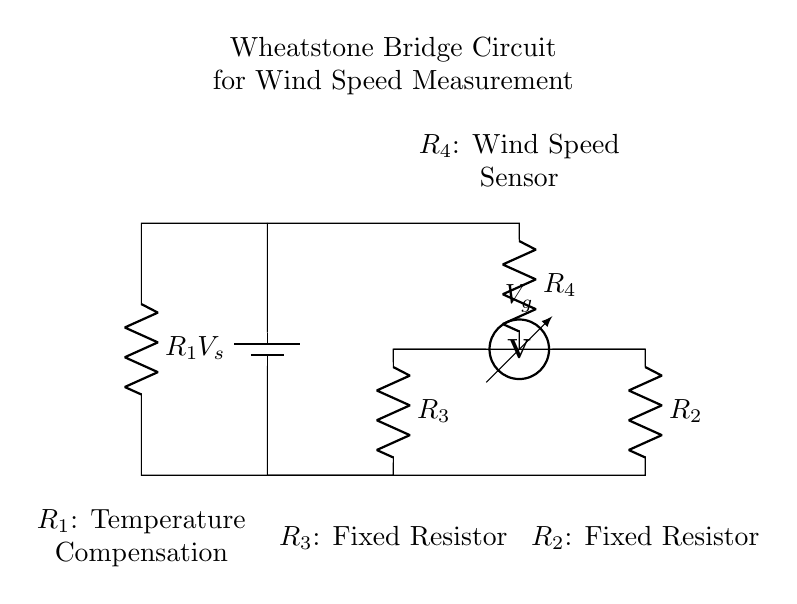What type of circuit is shown? The circuit is a Wheatstone bridge, which is characterized by its specific arrangement of resistors used for measuring resistance. The classic structure of a Wheatstone bridge includes four resistors arranged in a diamond shape, which is evidenced by the layout in the diagram.
Answer: Wheatstone bridge What is the function of R1? R1 is designated as a temperature compensation resistor, which adjusts for temperature variations affecting the measurement accuracy of the bridge. This support helps ensure that the bridge can maintain stability under different thermal conditions.
Answer: Temperature compensation How many resistors are present in the circuit? There are four resistors in the Wheatstone bridge, indicated by labels R1, R2, R3, and R4 in the schematic. The clear representation of four distinct resistor components confirms their number.
Answer: Four What does Vg represent? Vg represents the voltage across the bridge, which indicates the difference in voltage between the two sides of the bridge circuit for precise measurement. This measurement aids in assessing the resistance change due to the wind speed sensor R4.
Answer: Voltage across the bridge What role does R4 serve in the circuit? R4 is the wind speed sensor, which reacts to the wind's effect by altering its resistance. This change helps determine the corresponding voltage across the bridge, which can then be used to calculate wind speed. Therefore, R4 is crucial for the circuit's primary purpose.
Answer: Wind speed sensor What is the purpose of this circuit? The purpose of the Wheatstone bridge in this configuration is to precisely measure wind speed through the changes in resistance caused by environmental factors. This setup enables accurate readings that are essential for evaluating the efficiency and safety of wind turbines.
Answer: Measure wind speed 